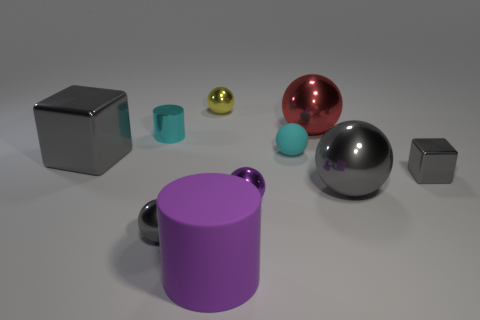What number of other things are the same size as the cyan metallic object?
Provide a succinct answer. 5. The large matte cylinder has what color?
Give a very brief answer. Purple. There is a big object left of the big purple matte cylinder; is it the same color as the matte object that is behind the purple metal ball?
Keep it short and to the point. No. How big is the metallic cylinder?
Keep it short and to the point. Small. There is a gray block to the left of the purple shiny thing; what is its size?
Ensure brevity in your answer.  Large. There is a small object that is both behind the big metallic cube and in front of the small metal cylinder; what shape is it?
Your response must be concise. Sphere. How many other objects are the same shape as the red metallic object?
Your response must be concise. 5. There is a block that is the same size as the matte ball; what is its color?
Your response must be concise. Gray. How many things are either large rubber cylinders or blue things?
Your answer should be very brief. 1. Are there any big gray metal things to the left of the tiny purple sphere?
Ensure brevity in your answer.  Yes. 